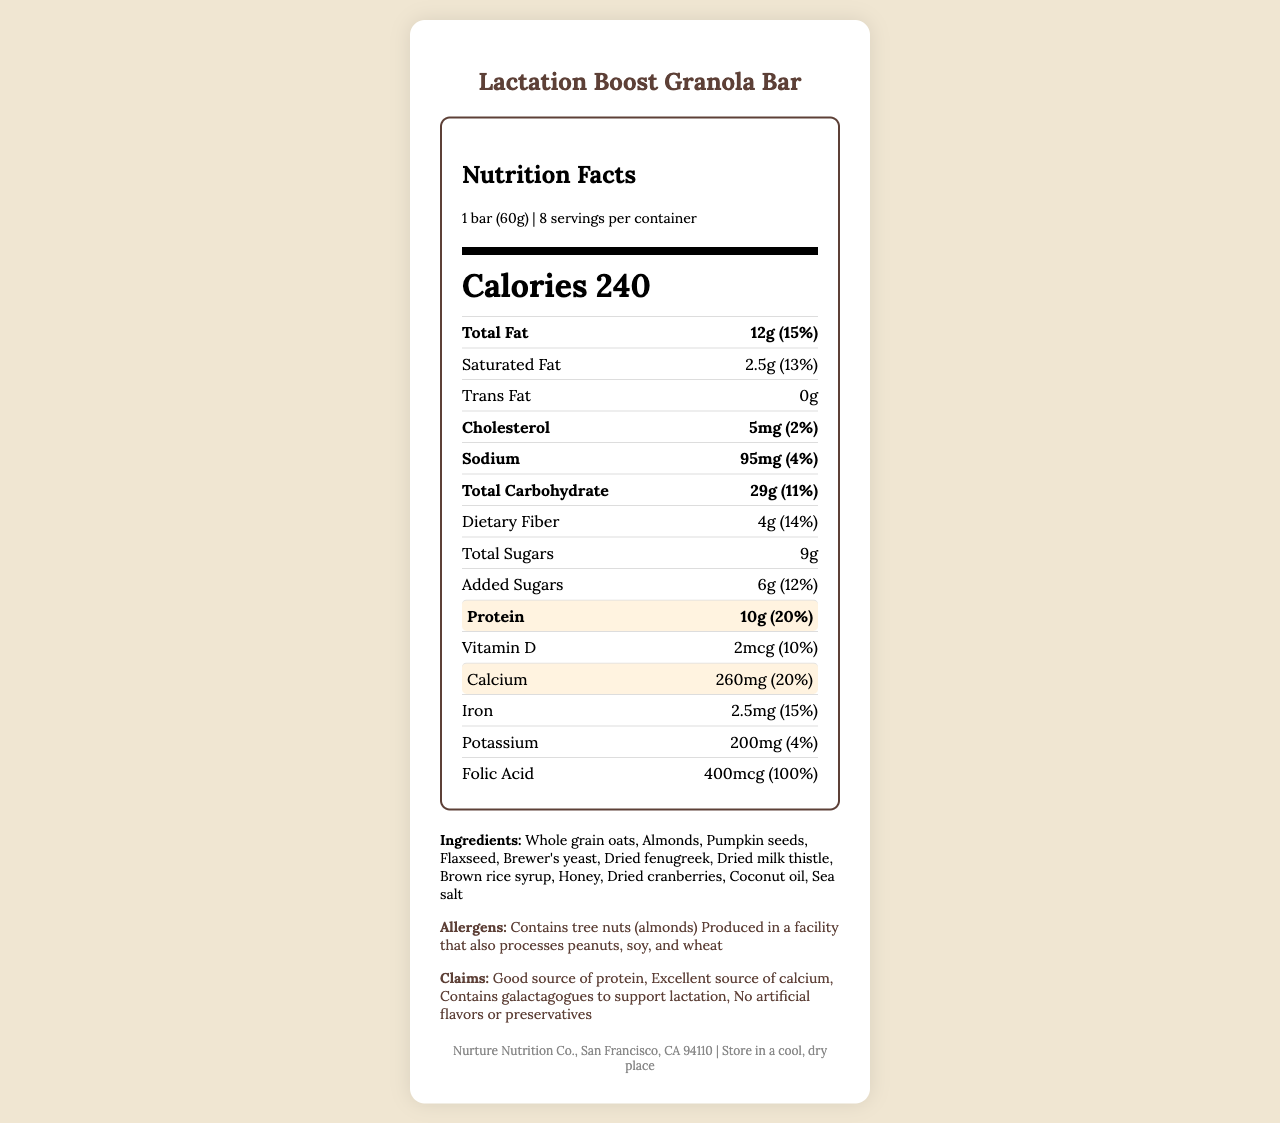how many grams of protein does one serving provide? The "Protein" section in the nutrition facts label lists 10g of protein per serving.
Answer: 10g what is the daily value percentage for calcium? The "Calcium" section states 260mg, which corresponds to 20% of the daily value.
Answer: 20% how many calories are in one bar? The "Calories" section lists 240 calories per serving, which is one bar.
Answer: 240 how much saturated fat is there in one serving? The "Saturated Fat" section shows 2.5g per serving.
Answer: 2.5g what is the serving size of the Lactation Boost Granola Bar? The "serving size" is listed as "1 bar (60g)" in the document.
Answer: 1 bar (60g) how much vitamin D does one bar have? The "Vitamin D" section lists 2mcg per serving.
Answer: 2mcg how much sodium is in each serving? The document specifies that there are 95mg of sodium per serving.
Answer: 95mg which of the following ingredients is not included in the granola bar? A. Almonds B. Pumpkin seeds C. Peanuts D. Flaxseed The ingredients list includes almonds, pumpkin seeds, and flaxseed, but does not mention peanuts.
Answer: C what is the percentage of daily value for protein? A. 10% B. 15% C. 20% D. 25% The "Protein" section lists the daily value percentage as 20%.
Answer: C is this product an excellent source of calcium? The document claims that this product is an "excellent source of calcium," and the nutrition facts confirm it with 20% daily value.
Answer: Yes what are the primary allergens mentioned for this product? The allergens section mentions that the product contains tree nuts (almonds).
Answer: Tree nuts list any two claims made by the manufacturer. The claims section lists multiple claims: "Good source of protein", "Excellent source of calcium", "Contains galactagogues to support lactation", and "No artificial flavors or preservatives."
Answer: Good source of protein, No artificial flavors or preservatives where should the product be stored? The storage information specifies to store the product in a cool, dry place.
Answer: In a cool, dry place what is the total fat content per serving? The "Total Fat" section lists 12g per serving.
Answer: 12g summarize the main features of the Lactation Boost Granola Bar. The document provides comprehensive nutritional information, ingredient lists, allergen warnings, and various claims supporting the product's benefits for lactating mothers.
Answer: The Lactation Boost Granola Bar is a product designed to support lactation, providing significant amounts of protein (10g) and calcium (260mg) per serving. It contains a variety of natural ingredients such as whole grain oats, almonds, and flaxseed, and includes galactagogues like brewer's yeast and dried fenugreek. The bar has 240 calories per serving and contains no artificial flavors or preservatives. It also outlines allergens, storage instructions, and its manufacturer. is there any information about the product's price in the document? The document does not provide any information about the price of the product.
Answer: No 